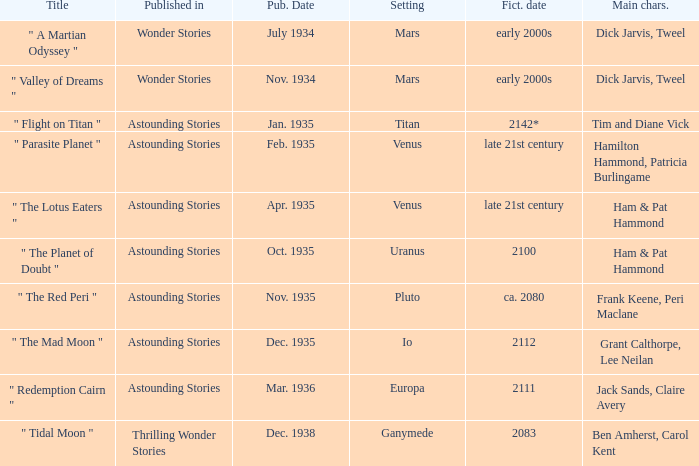Name what was published in july 1934 with a setting of mars Wonder Stories. 